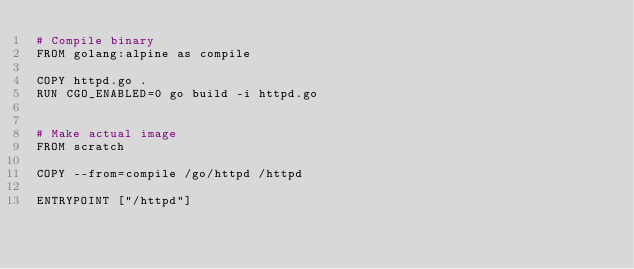<code> <loc_0><loc_0><loc_500><loc_500><_Dockerfile_># Compile binary
FROM golang:alpine as compile

COPY httpd.go .
RUN CGO_ENABLED=0 go build -i httpd.go


# Make actual image
FROM scratch

COPY --from=compile /go/httpd /httpd

ENTRYPOINT ["/httpd"]
</code> 